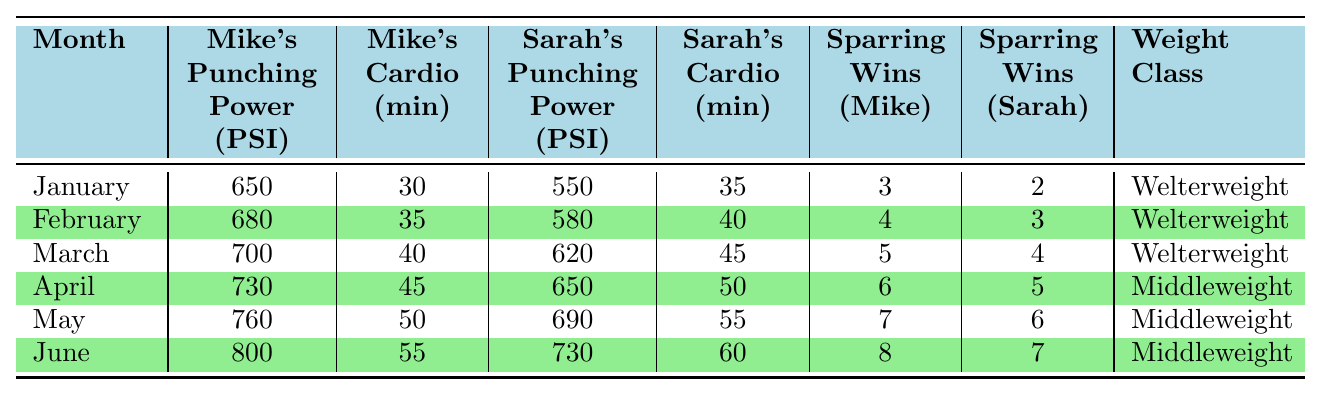What was Mike's punching power in June? From the table, we look at the row for June and see Mike's punching power listed as 800 PSI.
Answer: 800 PSI How many sparring wins did Sarah achieve in March? Referring to the table, in the row for March, Sarah's sparring wins are recorded as 4.
Answer: 4 What is the average cardio time for Mike over the six months? To calculate the average, we sum Mike's cardio times: (30 + 35 + 40 + 45 + 50 + 55) = 255 minutes. We then divide by 6 (number of months): 255/6 = 42.5 minutes.
Answer: 42.5 minutes Did Sarah's punching power increase every month? By checking the table, we observe that Sarah's punching power progresses as follows: 550, 580, 620, 650, 690, and 730 PSI. Since each month shows a higher value, the statement is true.
Answer: Yes What was the difference in boxing weight class between April and May? The weight class for April is Middleweight, and for May, it remains Middleweight. The difference is non-existent as they are the same.
Answer: None What was the total number of sparring wins for both siblings by the end of June? To find the total, we sum the sparring wins: (8 from Mike + 7 from Sarah) = 15 total sparring wins by June.
Answer: 15 In which month did Mike's cardio time exceed Sarah's cardio time? Reviewing the table, in June, Mike's cardio is 55 minutes and Sarah's is 60 minutes. In May, Mike's cardio (50 minutes) is less than Sarah's (55 minutes). Hence, Mike's cardio did not exceed Sarah's in any month.
Answer: No month What is the trend of Mike's punching power over the six-month period? Observing the table, Mike's punching power increases each month: 650, 680, 700, 730, 760, to 800 PSI, showing a consistent upward trend.
Answer: Increasing What was Sarah's average cardio time over the six months? Sarah's cardio times are (35 + 40 + 45 + 50 + 55 + 60) = 285 minutes. Dividing by 6 months gives us an average of 285/6 = 47.5 minutes.
Answer: 47.5 minutes How many more sparring wins did Mike have than Sarah in May? In May, Mike had 7 sparring wins, and Sarah had 6. The difference is 7 - 6 = 1 win more for Mike.
Answer: 1 win 